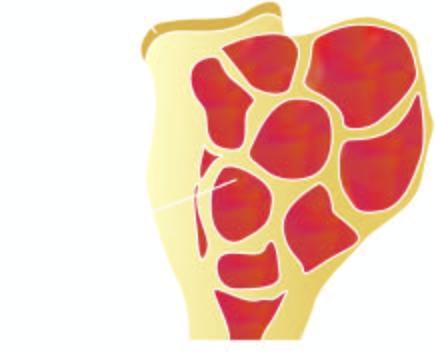does the sectioned surface of rectal wall show circumscribed, dark tan, haemorrhagic and necrotic tumour?
Answer the question using a single word or phrase. No 